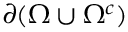<formula> <loc_0><loc_0><loc_500><loc_500>\partial ( \Omega \cup \Omega ^ { c } )</formula> 